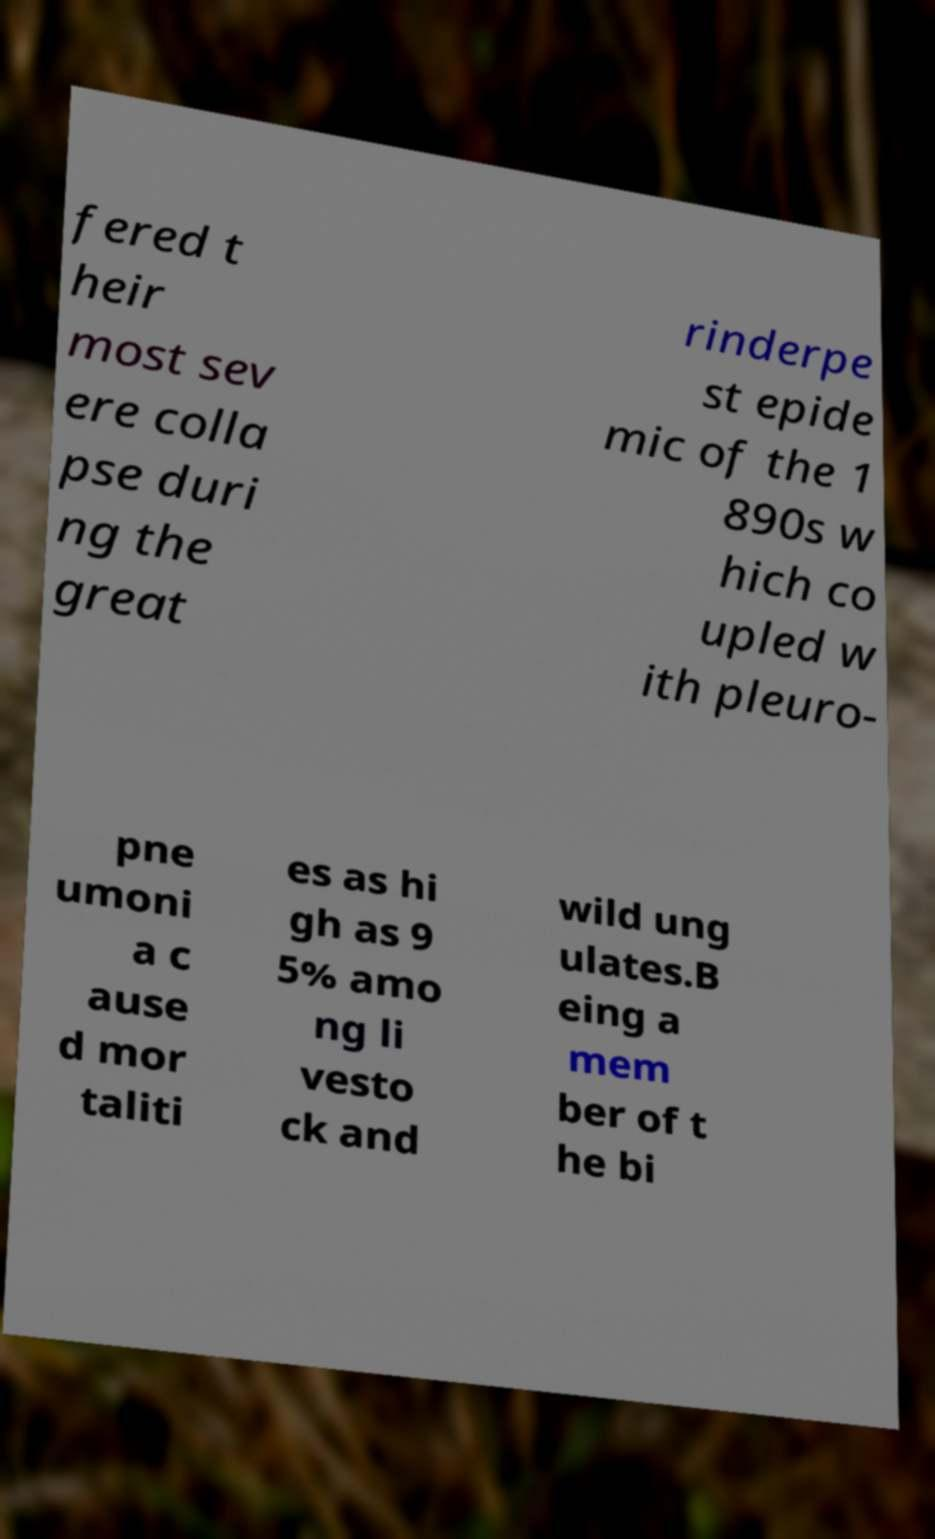Please identify and transcribe the text found in this image. fered t heir most sev ere colla pse duri ng the great rinderpe st epide mic of the 1 890s w hich co upled w ith pleuro- pne umoni a c ause d mor taliti es as hi gh as 9 5% amo ng li vesto ck and wild ung ulates.B eing a mem ber of t he bi 